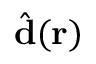Convert formula to latex. <formula><loc_0><loc_0><loc_500><loc_500>\hat { d } ( r )</formula> 